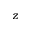<formula> <loc_0><loc_0><loc_500><loc_500>z</formula> 